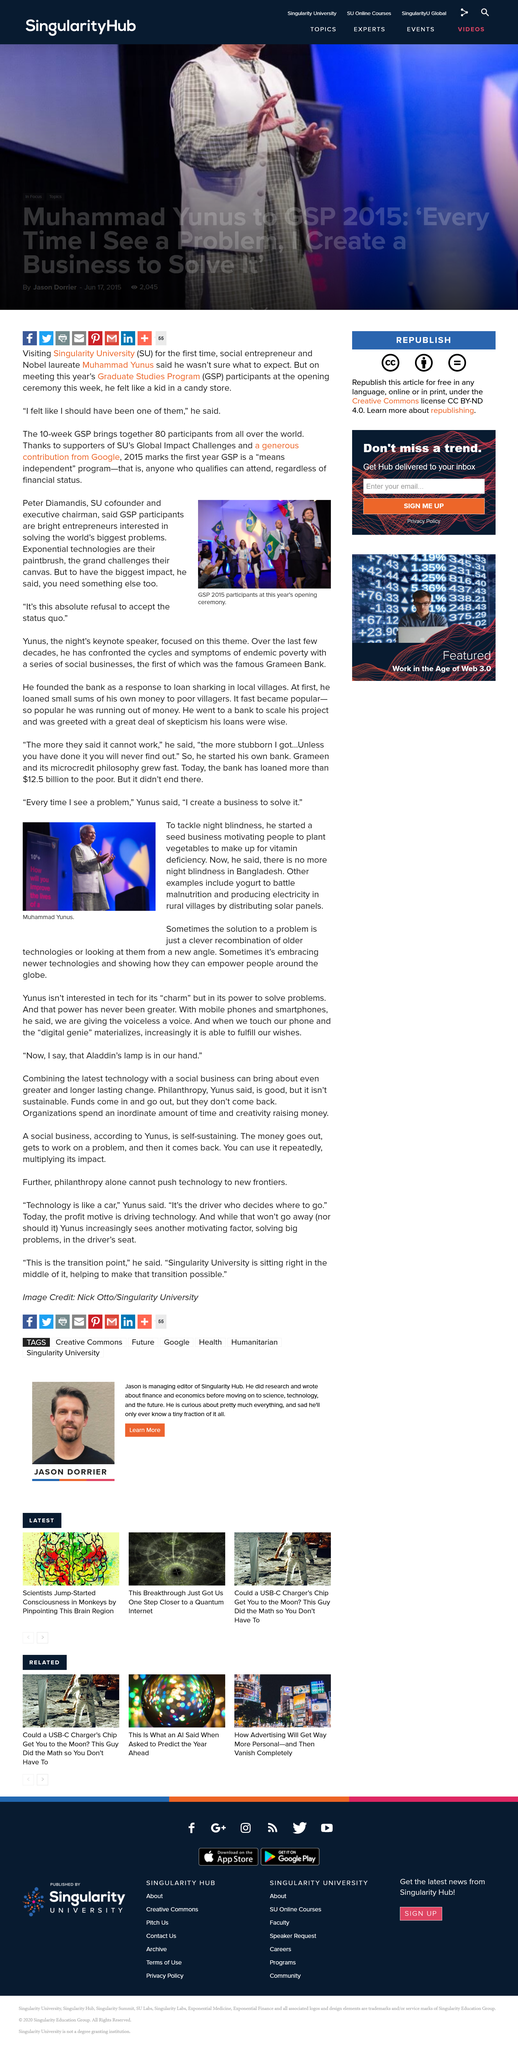Indicate a few pertinent items in this graphic. The article is about a person named Muhammad. Yunus is the surname of the person in the article who states, "Every time I see a problem, I create a business to solve it. Peter Diamandis is the Co-Founder and Executive Chairman of the Singularity University. The article states that in Bangladesh, there is no longer any occurrence of night blindness. Participants of the GSP 2015 at the opening ceremony can be seen in the photograph. 